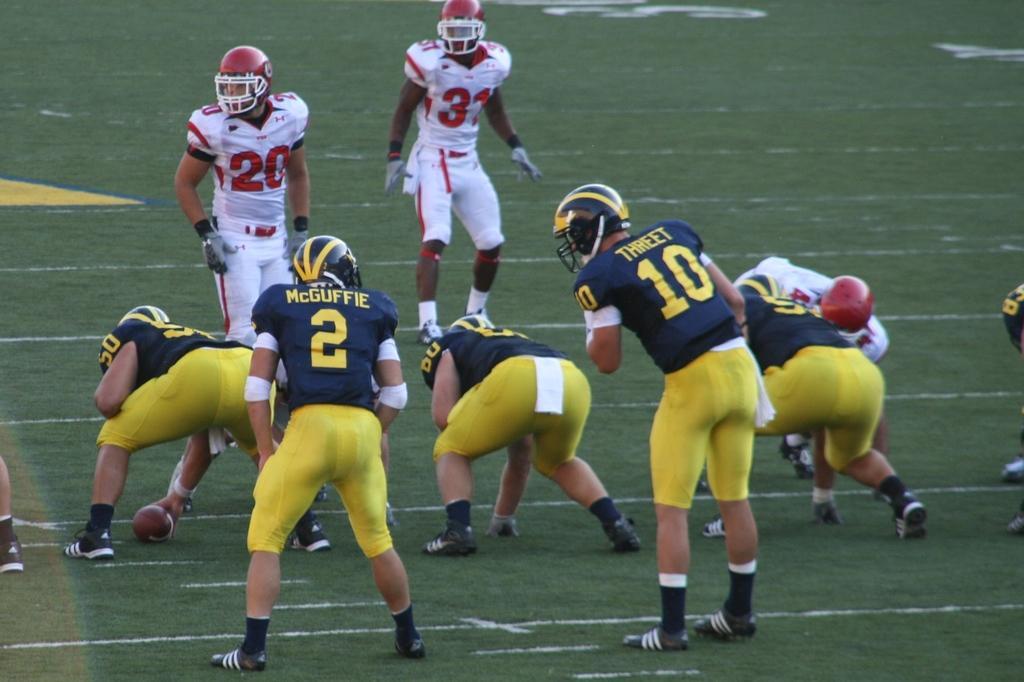Could you give a brief overview of what you see in this image? In the image few people are standing and watching and playing rugby ball. Behind them there is grass. 